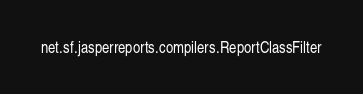Convert code to text. <code><loc_0><loc_0><loc_500><loc_500><_Rust_>net.sf.jasperreports.compilers.ReportClassFilter
</code> 